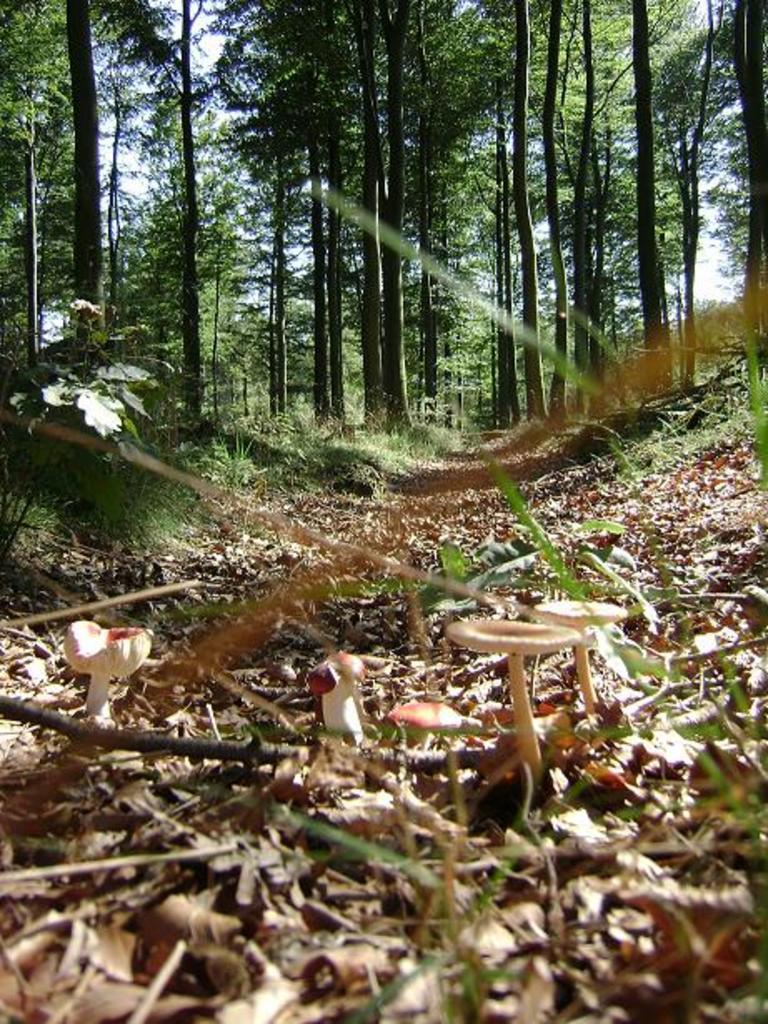What type of vegetation is visible in the image? There are many trees in the image. What can be found on the ground among the trees? Dry leaves are present in the image. Are there any fungi visible in the image? Yes, there are mushrooms in the image. What is the color of the sky in the image? The sky is white in the image. What type of zephyr can be seen blowing through the trees in the image? There is no zephyr present in the image; it is a still scene with no wind visible. How does the sleet affect the mushrooms in the image? There is no sleet present in the image; the mushrooms are dry and not affected by any precipitation. 